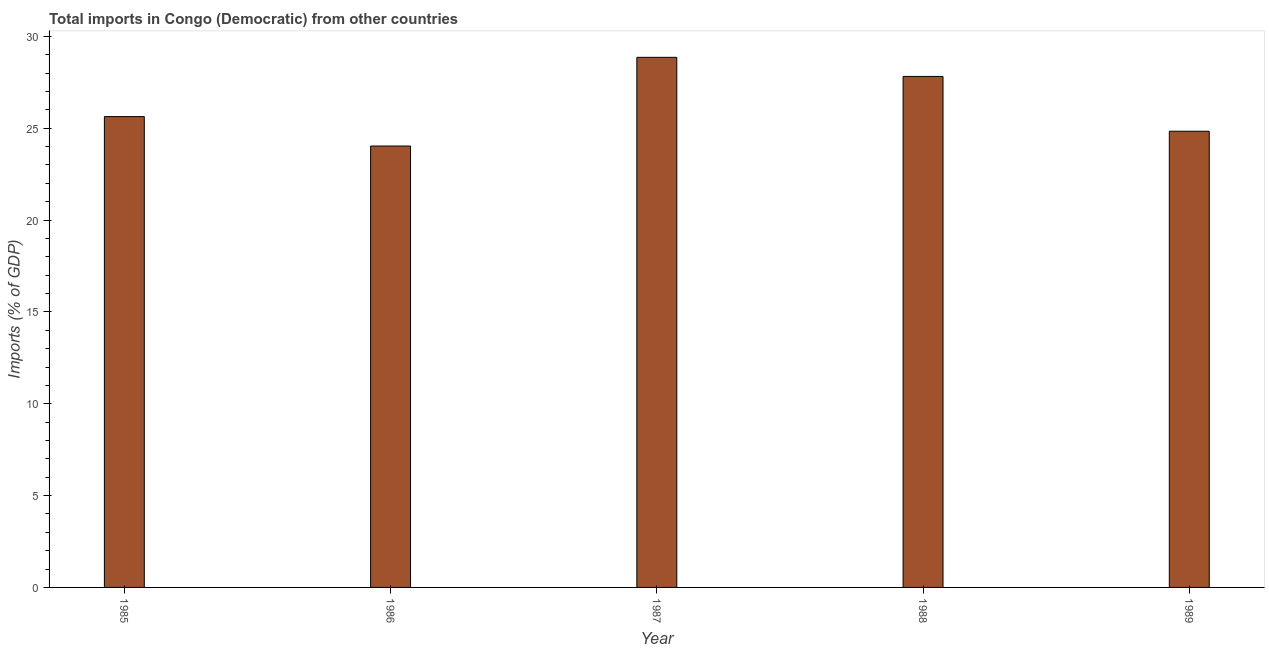Does the graph contain any zero values?
Make the answer very short. No. Does the graph contain grids?
Make the answer very short. No. What is the title of the graph?
Offer a terse response. Total imports in Congo (Democratic) from other countries. What is the label or title of the X-axis?
Your answer should be very brief. Year. What is the label or title of the Y-axis?
Ensure brevity in your answer.  Imports (% of GDP). What is the total imports in 1988?
Provide a short and direct response. 27.82. Across all years, what is the maximum total imports?
Your answer should be very brief. 28.86. Across all years, what is the minimum total imports?
Your answer should be very brief. 24.03. In which year was the total imports maximum?
Offer a terse response. 1987. What is the sum of the total imports?
Make the answer very short. 131.19. What is the difference between the total imports in 1986 and 1987?
Ensure brevity in your answer.  -4.83. What is the average total imports per year?
Your answer should be very brief. 26.24. What is the median total imports?
Your response must be concise. 25.63. What is the ratio of the total imports in 1987 to that in 1988?
Ensure brevity in your answer.  1.04. What is the difference between the highest and the second highest total imports?
Keep it short and to the point. 1.04. Is the sum of the total imports in 1985 and 1986 greater than the maximum total imports across all years?
Your answer should be compact. Yes. What is the difference between the highest and the lowest total imports?
Your response must be concise. 4.83. In how many years, is the total imports greater than the average total imports taken over all years?
Make the answer very short. 2. How many bars are there?
Your answer should be very brief. 5. How many years are there in the graph?
Provide a short and direct response. 5. What is the Imports (% of GDP) of 1985?
Offer a terse response. 25.63. What is the Imports (% of GDP) of 1986?
Your answer should be very brief. 24.03. What is the Imports (% of GDP) of 1987?
Keep it short and to the point. 28.86. What is the Imports (% of GDP) in 1988?
Your response must be concise. 27.82. What is the Imports (% of GDP) in 1989?
Offer a terse response. 24.84. What is the difference between the Imports (% of GDP) in 1985 and 1986?
Provide a short and direct response. 1.6. What is the difference between the Imports (% of GDP) in 1985 and 1987?
Provide a short and direct response. -3.23. What is the difference between the Imports (% of GDP) in 1985 and 1988?
Offer a very short reply. -2.19. What is the difference between the Imports (% of GDP) in 1985 and 1989?
Ensure brevity in your answer.  0.8. What is the difference between the Imports (% of GDP) in 1986 and 1987?
Ensure brevity in your answer.  -4.83. What is the difference between the Imports (% of GDP) in 1986 and 1988?
Provide a succinct answer. -3.79. What is the difference between the Imports (% of GDP) in 1986 and 1989?
Provide a short and direct response. -0.81. What is the difference between the Imports (% of GDP) in 1987 and 1988?
Make the answer very short. 1.04. What is the difference between the Imports (% of GDP) in 1987 and 1989?
Ensure brevity in your answer.  4.02. What is the difference between the Imports (% of GDP) in 1988 and 1989?
Provide a succinct answer. 2.98. What is the ratio of the Imports (% of GDP) in 1985 to that in 1986?
Ensure brevity in your answer.  1.07. What is the ratio of the Imports (% of GDP) in 1985 to that in 1987?
Your answer should be very brief. 0.89. What is the ratio of the Imports (% of GDP) in 1985 to that in 1988?
Ensure brevity in your answer.  0.92. What is the ratio of the Imports (% of GDP) in 1985 to that in 1989?
Give a very brief answer. 1.03. What is the ratio of the Imports (% of GDP) in 1986 to that in 1987?
Give a very brief answer. 0.83. What is the ratio of the Imports (% of GDP) in 1986 to that in 1988?
Your answer should be compact. 0.86. What is the ratio of the Imports (% of GDP) in 1987 to that in 1988?
Make the answer very short. 1.04. What is the ratio of the Imports (% of GDP) in 1987 to that in 1989?
Provide a short and direct response. 1.16. What is the ratio of the Imports (% of GDP) in 1988 to that in 1989?
Your answer should be compact. 1.12. 